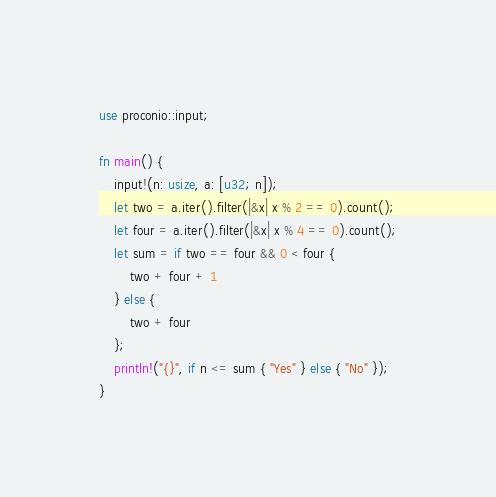Convert code to text. <code><loc_0><loc_0><loc_500><loc_500><_Rust_>use proconio::input;

fn main() {
    input!(n: usize, a: [u32; n]);
    let two = a.iter().filter(|&x| x % 2 == 0).count();
    let four = a.iter().filter(|&x| x % 4 == 0).count();
    let sum = if two == four && 0 < four {
        two + four + 1
    } else {
        two + four
    };
    println!("{}", if n <= sum { "Yes" } else { "No" });
}
</code> 